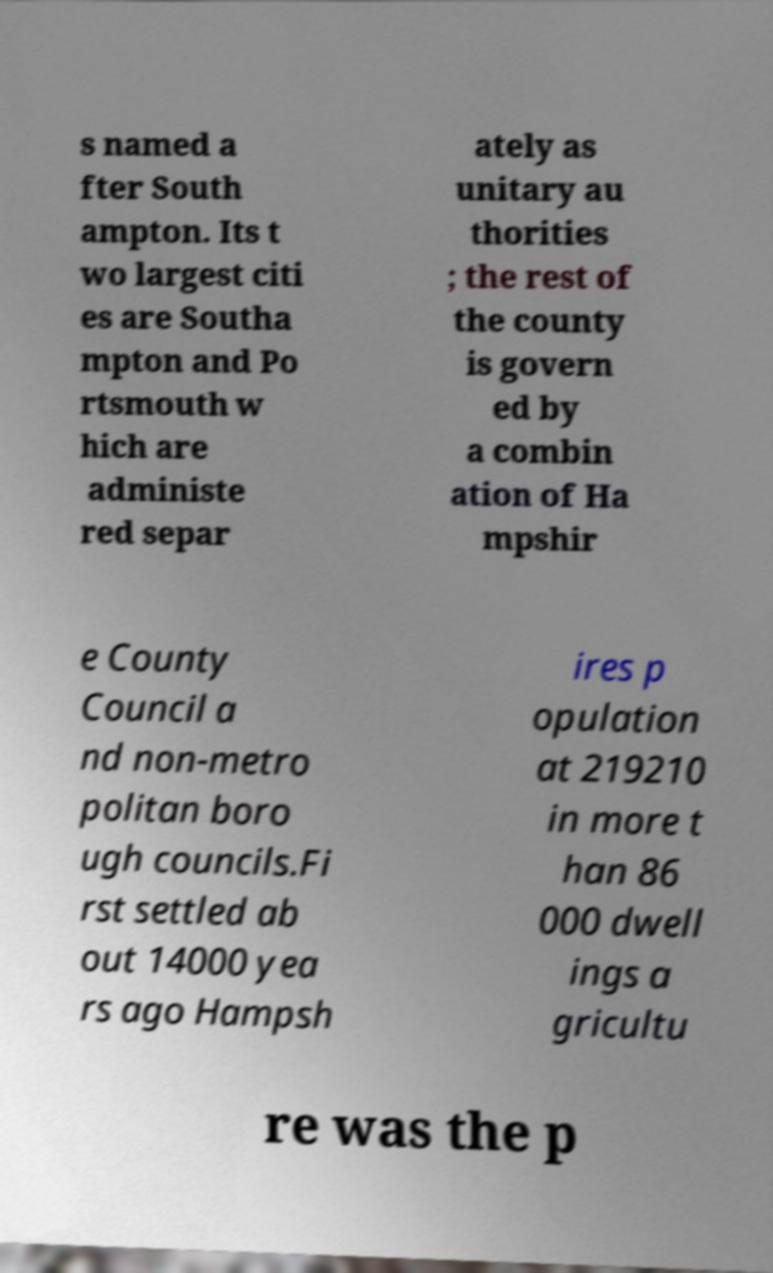Please read and relay the text visible in this image. What does it say? s named a fter South ampton. Its t wo largest citi es are Southa mpton and Po rtsmouth w hich are administe red separ ately as unitary au thorities ; the rest of the county is govern ed by a combin ation of Ha mpshir e County Council a nd non-metro politan boro ugh councils.Fi rst settled ab out 14000 yea rs ago Hampsh ires p opulation at 219210 in more t han 86 000 dwell ings a gricultu re was the p 